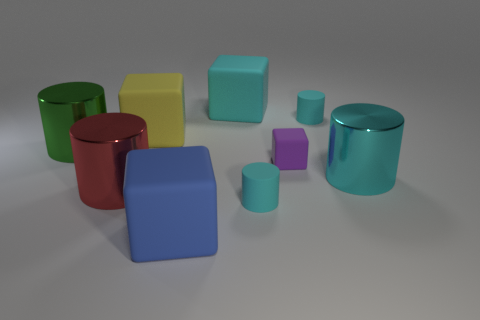What is the size of the rubber cylinder that is to the right of the cyan rubber cylinder to the left of the small purple object?
Provide a succinct answer. Small. Is the color of the small rubber block the same as the large metal cylinder that is right of the blue matte cube?
Keep it short and to the point. No. What number of cyan shiny things are on the left side of the big green thing?
Ensure brevity in your answer.  0. Is the number of small cyan matte cubes less than the number of large blue rubber cubes?
Provide a short and direct response. Yes. How big is the cylinder that is to the right of the red metallic thing and behind the purple cube?
Offer a terse response. Small. Does the big cylinder on the left side of the red shiny cylinder have the same color as the tiny rubber block?
Offer a terse response. No. Are there fewer metal cylinders that are behind the purple rubber object than small brown cylinders?
Provide a succinct answer. No. What is the shape of the large cyan thing that is the same material as the big yellow object?
Offer a very short reply. Cube. Is the material of the small purple cube the same as the large cyan cube?
Keep it short and to the point. Yes. Is the number of big metal cylinders that are on the left side of the cyan metal cylinder less than the number of cyan rubber things that are in front of the blue matte block?
Provide a succinct answer. No. 